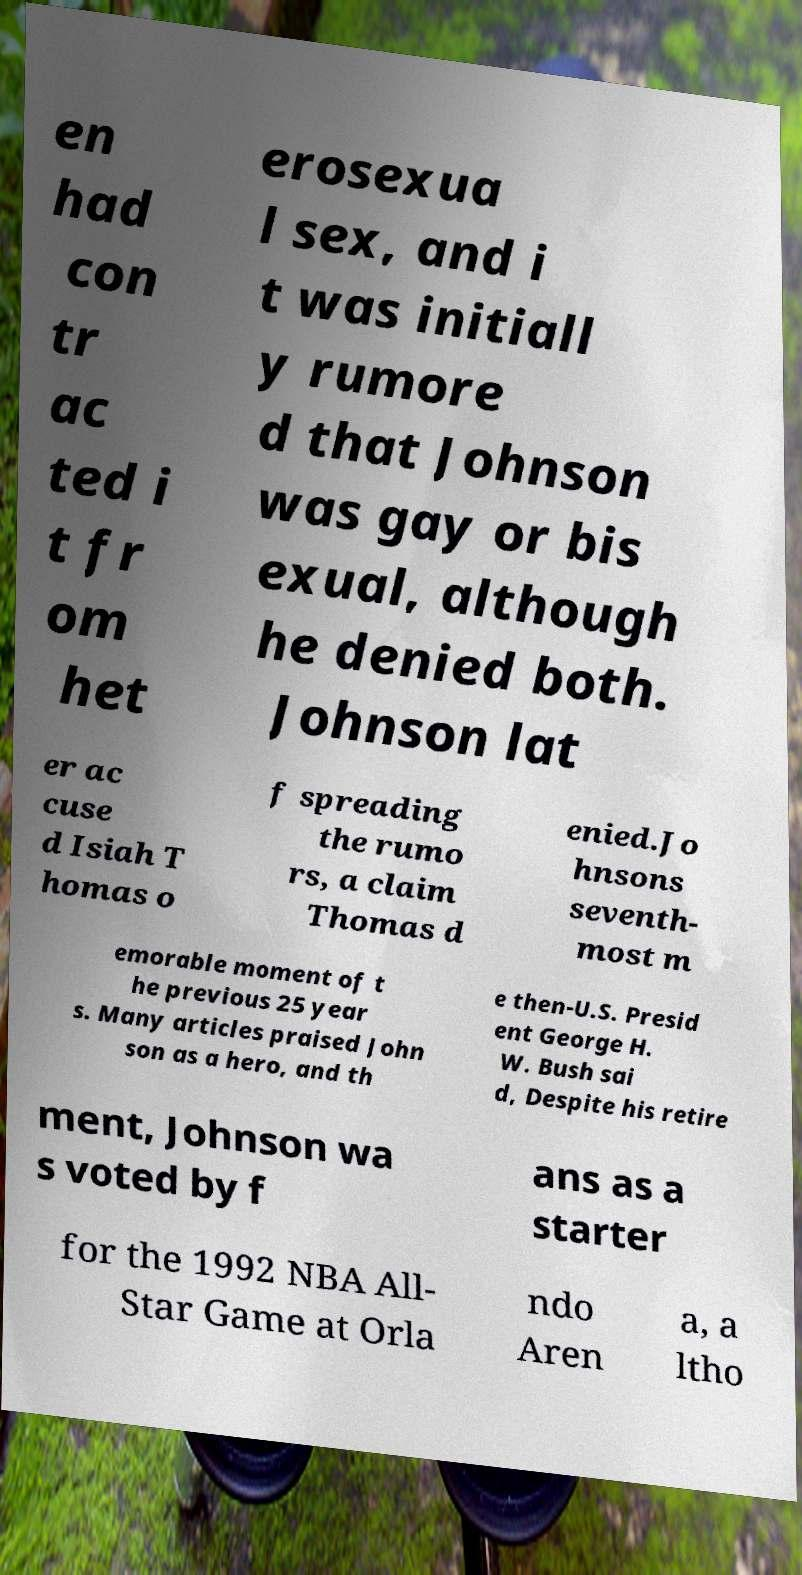Can you accurately transcribe the text from the provided image for me? en had con tr ac ted i t fr om het erosexua l sex, and i t was initiall y rumore d that Johnson was gay or bis exual, although he denied both. Johnson lat er ac cuse d Isiah T homas o f spreading the rumo rs, a claim Thomas d enied.Jo hnsons seventh- most m emorable moment of t he previous 25 year s. Many articles praised John son as a hero, and th e then-U.S. Presid ent George H. W. Bush sai d, Despite his retire ment, Johnson wa s voted by f ans as a starter for the 1992 NBA All- Star Game at Orla ndo Aren a, a ltho 